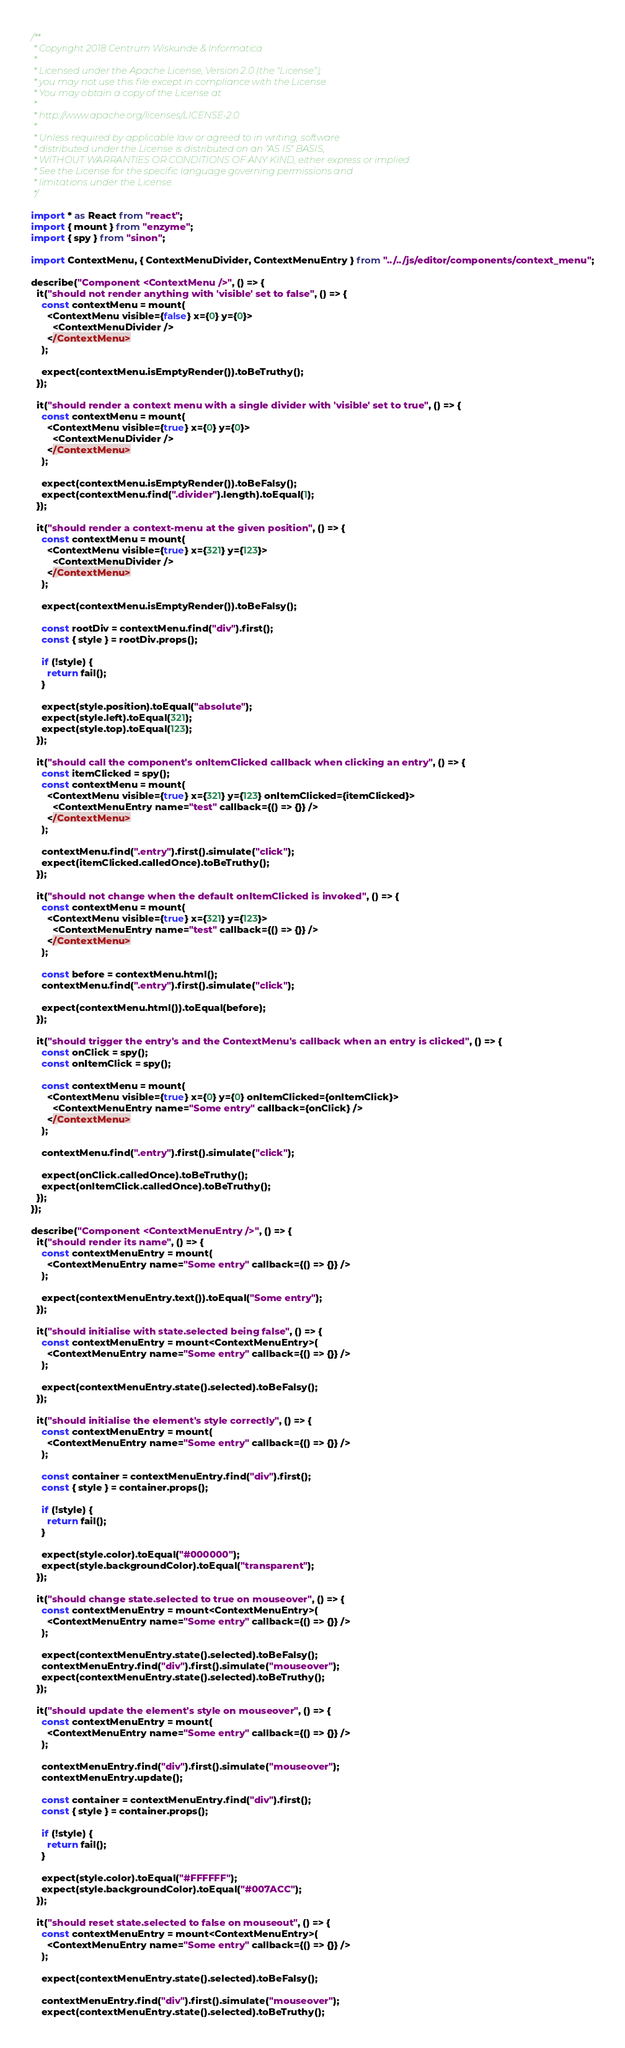<code> <loc_0><loc_0><loc_500><loc_500><_TypeScript_>/**
 * Copyright 2018 Centrum Wiskunde & Informatica
 *
 * Licensed under the Apache License, Version 2.0 (the "License");
 * you may not use this file except in compliance with the License.
 * You may obtain a copy of the License at
 *
 * http://www.apache.org/licenses/LICENSE-2.0
 *
 * Unless required by applicable law or agreed to in writing, software
 * distributed under the License is distributed on an "AS IS" BASIS,
 * WITHOUT WARRANTIES OR CONDITIONS OF ANY KIND, either express or implied.
 * See the License for the specific language governing permissions and
 * limitations under the License.
 */

import * as React from "react";
import { mount } from "enzyme";
import { spy } from "sinon";

import ContextMenu, { ContextMenuDivider, ContextMenuEntry } from "../../js/editor/components/context_menu";

describe("Component <ContextMenu />", () => {
  it("should not render anything with 'visible' set to false", () => {
    const contextMenu = mount(
      <ContextMenu visible={false} x={0} y={0}>
        <ContextMenuDivider />
      </ContextMenu>
    );

    expect(contextMenu.isEmptyRender()).toBeTruthy();
  });

  it("should render a context menu with a single divider with 'visible' set to true", () => {
    const contextMenu = mount(
      <ContextMenu visible={true} x={0} y={0}>
        <ContextMenuDivider />
      </ContextMenu>
    );

    expect(contextMenu.isEmptyRender()).toBeFalsy();
    expect(contextMenu.find(".divider").length).toEqual(1);
  });

  it("should render a context-menu at the given position", () => {
    const contextMenu = mount(
      <ContextMenu visible={true} x={321} y={123}>
        <ContextMenuDivider />
      </ContextMenu>
    );

    expect(contextMenu.isEmptyRender()).toBeFalsy();

    const rootDiv = contextMenu.find("div").first();
    const { style } = rootDiv.props();

    if (!style) {
      return fail();
    }

    expect(style.position).toEqual("absolute");
    expect(style.left).toEqual(321);
    expect(style.top).toEqual(123);
  });

  it("should call the component's onItemClicked callback when clicking an entry", () => {
    const itemClicked = spy();
    const contextMenu = mount(
      <ContextMenu visible={true} x={321} y={123} onItemClicked={itemClicked}>
        <ContextMenuEntry name="test" callback={() => {}} />
      </ContextMenu>
    );

    contextMenu.find(".entry").first().simulate("click");
    expect(itemClicked.calledOnce).toBeTruthy();
  });

  it("should not change when the default onItemClicked is invoked", () => {
    const contextMenu = mount(
      <ContextMenu visible={true} x={321} y={123}>
        <ContextMenuEntry name="test" callback={() => {}} />
      </ContextMenu>
    );

    const before = contextMenu.html();
    contextMenu.find(".entry").first().simulate("click");

    expect(contextMenu.html()).toEqual(before);
  });

  it("should trigger the entry's and the ContextMenu's callback when an entry is clicked", () => {
    const onClick = spy();
    const onItemClick = spy();

    const contextMenu = mount(
      <ContextMenu visible={true} x={0} y={0} onItemClicked={onItemClick}>
        <ContextMenuEntry name="Some entry" callback={onClick} />
      </ContextMenu>
    );

    contextMenu.find(".entry").first().simulate("click");

    expect(onClick.calledOnce).toBeTruthy();
    expect(onItemClick.calledOnce).toBeTruthy();
  });
});

describe("Component <ContextMenuEntry />", () => {
  it("should render its name", () => {
    const contextMenuEntry = mount(
      <ContextMenuEntry name="Some entry" callback={() => {}} />
    );

    expect(contextMenuEntry.text()).toEqual("Some entry");
  });

  it("should initialise with state.selected being false", () => {
    const contextMenuEntry = mount<ContextMenuEntry>(
      <ContextMenuEntry name="Some entry" callback={() => {}} />
    );

    expect(contextMenuEntry.state().selected).toBeFalsy();
  });

  it("should initialise the element's style correctly", () => {
    const contextMenuEntry = mount(
      <ContextMenuEntry name="Some entry" callback={() => {}} />
    );

    const container = contextMenuEntry.find("div").first();
    const { style } = container.props();

    if (!style) {
      return fail();
    }

    expect(style.color).toEqual("#000000");
    expect(style.backgroundColor).toEqual("transparent");
  });

  it("should change state.selected to true on mouseover", () => {
    const contextMenuEntry = mount<ContextMenuEntry>(
      <ContextMenuEntry name="Some entry" callback={() => {}} />
    );

    expect(contextMenuEntry.state().selected).toBeFalsy();
    contextMenuEntry.find("div").first().simulate("mouseover");
    expect(contextMenuEntry.state().selected).toBeTruthy();
  });

  it("should update the element's style on mouseover", () => {
    const contextMenuEntry = mount(
      <ContextMenuEntry name="Some entry" callback={() => {}} />
    );

    contextMenuEntry.find("div").first().simulate("mouseover");
    contextMenuEntry.update();

    const container = contextMenuEntry.find("div").first();
    const { style } = container.props();

    if (!style) {
      return fail();
    }

    expect(style.color).toEqual("#FFFFFF");
    expect(style.backgroundColor).toEqual("#007ACC");
  });

  it("should reset state.selected to false on mouseout", () => {
    const contextMenuEntry = mount<ContextMenuEntry>(
      <ContextMenuEntry name="Some entry" callback={() => {}} />
    );

    expect(contextMenuEntry.state().selected).toBeFalsy();

    contextMenuEntry.find("div").first().simulate("mouseover");
    expect(contextMenuEntry.state().selected).toBeTruthy();
</code> 